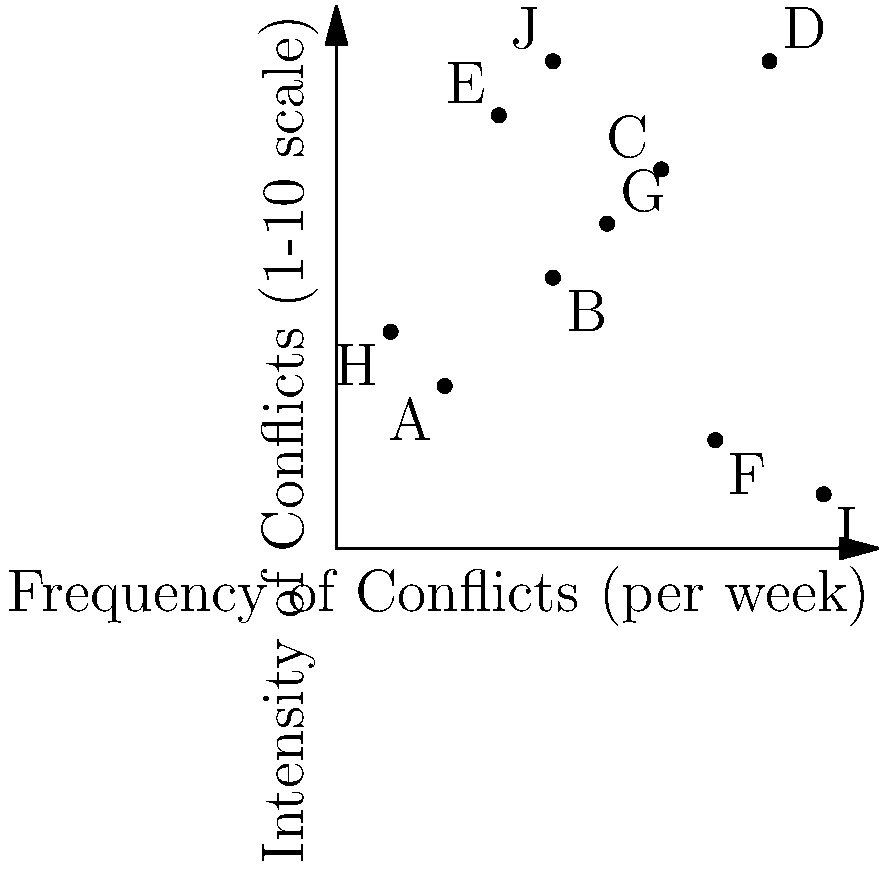As a psychologist specializing in interpersonal relationships, you're analyzing data on conflict patterns in couples. The scatter plot above represents the frequency and intensity of conflicts for 10 different couples (labeled A through J). Which couple experiences the highest frequency of conflicts with the lowest intensity, and what might this pattern suggest about their relationship dynamics? To answer this question, we need to analyze the scatter plot step-by-step:

1. Understand the axes:
   - X-axis: Frequency of conflicts per week
   - Y-axis: Intensity of conflicts on a 1-10 scale

2. Identify the couple with the highest frequency and lowest intensity:
   - Look for points furthest to the right (high frequency) and closest to the bottom (low intensity)
   - Point I (9,1) represents the couple with the highest frequency (9 conflicts per week) and lowest intensity (1 on the scale)

3. Interpret the relationship dynamics:
   - High frequency of conflicts suggests frequent disagreements or issues
   - Low intensity indicates these conflicts are not severe or emotionally charged
   - This pattern might suggest:
     a. The couple has many minor disagreements but resolves them without escalation
     b. They may have good communication skills for addressing issues promptly
     c. There might be underlying tensions or unresolved issues leading to frequent minor conflicts
     d. The couple might benefit from exploring the root causes of their frequent disagreements

4. Consider the implications:
   - While the low intensity is positive, the high frequency may indicate a need for improvement in problem-solving or conflict prevention
   - The couple might benefit from therapy focused on identifying patterns and developing strategies to reduce the frequency of conflicts
Answer: Couple I; frequent minor conflicts suggesting good communication but potential underlying issues. 